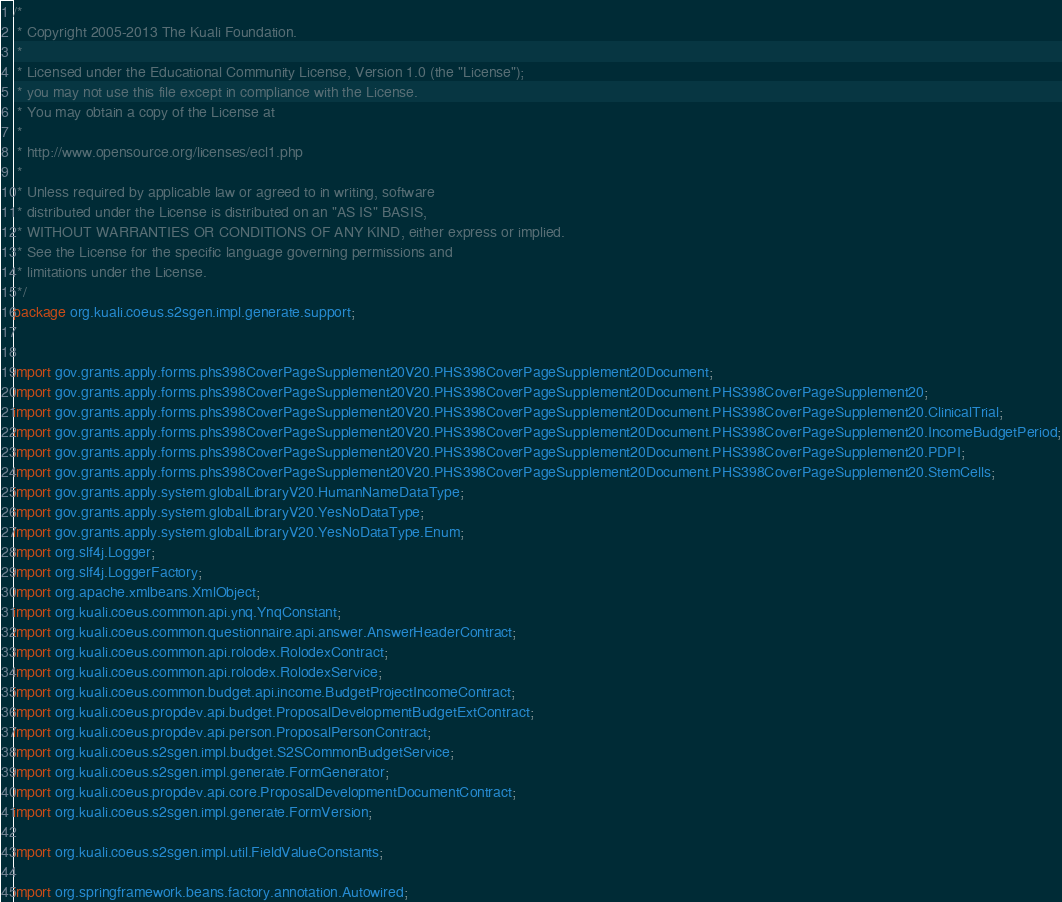Convert code to text. <code><loc_0><loc_0><loc_500><loc_500><_Java_>/*
 * Copyright 2005-2013 The Kuali Foundation.
 * 
 * Licensed under the Educational Community License, Version 1.0 (the "License");
 * you may not use this file except in compliance with the License.
 * You may obtain a copy of the License at
 * 
 * http://www.opensource.org/licenses/ecl1.php
 * 
 * Unless required by applicable law or agreed to in writing, software
 * distributed under the License is distributed on an "AS IS" BASIS,
 * WITHOUT WARRANTIES OR CONDITIONS OF ANY KIND, either express or implied.
 * See the License for the specific language governing permissions and
 * limitations under the License.
 */
package org.kuali.coeus.s2sgen.impl.generate.support;


import gov.grants.apply.forms.phs398CoverPageSupplement20V20.PHS398CoverPageSupplement20Document;
import gov.grants.apply.forms.phs398CoverPageSupplement20V20.PHS398CoverPageSupplement20Document.PHS398CoverPageSupplement20;
import gov.grants.apply.forms.phs398CoverPageSupplement20V20.PHS398CoverPageSupplement20Document.PHS398CoverPageSupplement20.ClinicalTrial;
import gov.grants.apply.forms.phs398CoverPageSupplement20V20.PHS398CoverPageSupplement20Document.PHS398CoverPageSupplement20.IncomeBudgetPeriod;
import gov.grants.apply.forms.phs398CoverPageSupplement20V20.PHS398CoverPageSupplement20Document.PHS398CoverPageSupplement20.PDPI;
import gov.grants.apply.forms.phs398CoverPageSupplement20V20.PHS398CoverPageSupplement20Document.PHS398CoverPageSupplement20.StemCells;
import gov.grants.apply.system.globalLibraryV20.HumanNameDataType;
import gov.grants.apply.system.globalLibraryV20.YesNoDataType;
import gov.grants.apply.system.globalLibraryV20.YesNoDataType.Enum;
import org.slf4j.Logger;
import org.slf4j.LoggerFactory;
import org.apache.xmlbeans.XmlObject;
import org.kuali.coeus.common.api.ynq.YnqConstant;
import org.kuali.coeus.common.questionnaire.api.answer.AnswerHeaderContract;
import org.kuali.coeus.common.api.rolodex.RolodexContract;
import org.kuali.coeus.common.api.rolodex.RolodexService;
import org.kuali.coeus.common.budget.api.income.BudgetProjectIncomeContract;
import org.kuali.coeus.propdev.api.budget.ProposalDevelopmentBudgetExtContract;
import org.kuali.coeus.propdev.api.person.ProposalPersonContract;
import org.kuali.coeus.s2sgen.impl.budget.S2SCommonBudgetService;
import org.kuali.coeus.s2sgen.impl.generate.FormGenerator;
import org.kuali.coeus.propdev.api.core.ProposalDevelopmentDocumentContract;
import org.kuali.coeus.s2sgen.impl.generate.FormVersion;

import org.kuali.coeus.s2sgen.impl.util.FieldValueConstants;

import org.springframework.beans.factory.annotation.Autowired;</code> 